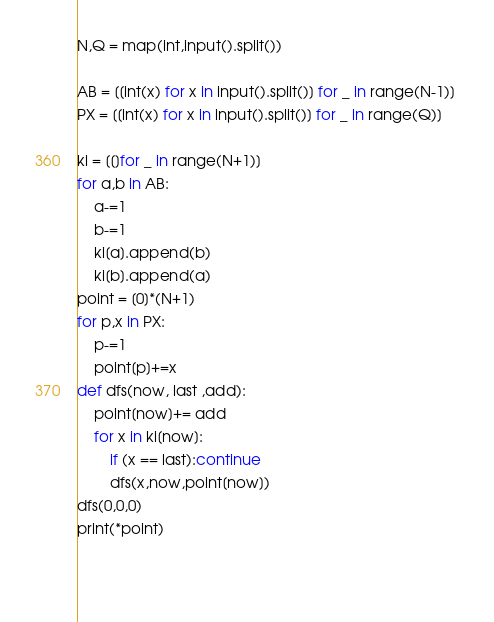<code> <loc_0><loc_0><loc_500><loc_500><_Python_>N,Q = map(int,input().split())
 
AB = [[int(x) for x in input().split()] for _ in range(N-1)] 
PX = [[int(x) for x in input().split()] for _ in range(Q)]

ki = [[]for _ in range(N+1)]
for a,b in AB:
    a-=1
    b-=1
    ki[a].append(b)
    ki[b].append(a)
point = [0]*(N+1)
for p,x in PX:
    p-=1
    point[p]+=x
def dfs(now, last ,add):
    point[now]+= add
    for x in ki[now]:
        if (x == last):continue
        dfs(x,now,point[now])
dfs(0,0,0)
print(*point)
    
    </code> 